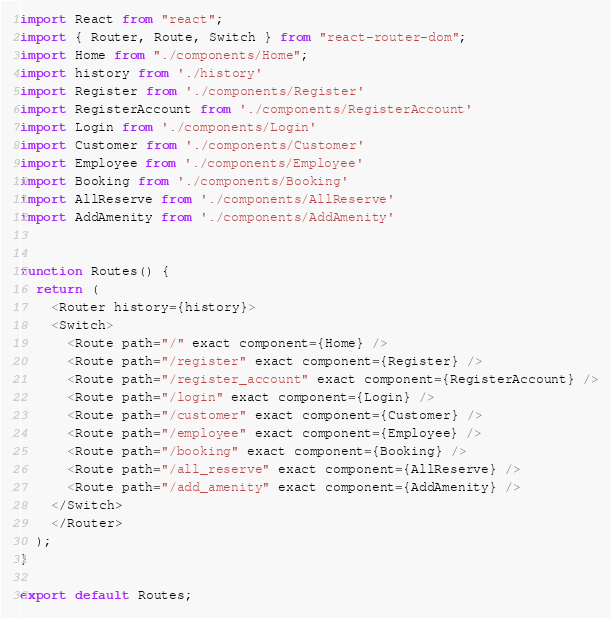Convert code to text. <code><loc_0><loc_0><loc_500><loc_500><_JavaScript_>import React from "react";
import { Router, Route, Switch } from "react-router-dom";
import Home from "./components/Home";
import history from './history'
import Register from './components/Register'
import RegisterAccount from './components/RegisterAccount'
import Login from './components/Login'
import Customer from './components/Customer'
import Employee from './components/Employee'
import Booking from './components/Booking'
import AllReserve from './components/AllReserve'
import AddAmenity from './components/AddAmenity'


function Routes() {
  return (
    <Router history={history}>
    <Switch>
      <Route path="/" exact component={Home} />
      <Route path="/register" exact component={Register} />
      <Route path="/register_account" exact component={RegisterAccount} />
      <Route path="/login" exact component={Login} />
      <Route path="/customer" exact component={Customer} />
      <Route path="/employee" exact component={Employee} />
      <Route path="/booking" exact component={Booking} />
      <Route path="/all_reserve" exact component={AllReserve} />
      <Route path="/add_amenity" exact component={AddAmenity} />
    </Switch>
    </Router>
  );
}

export default Routes;</code> 